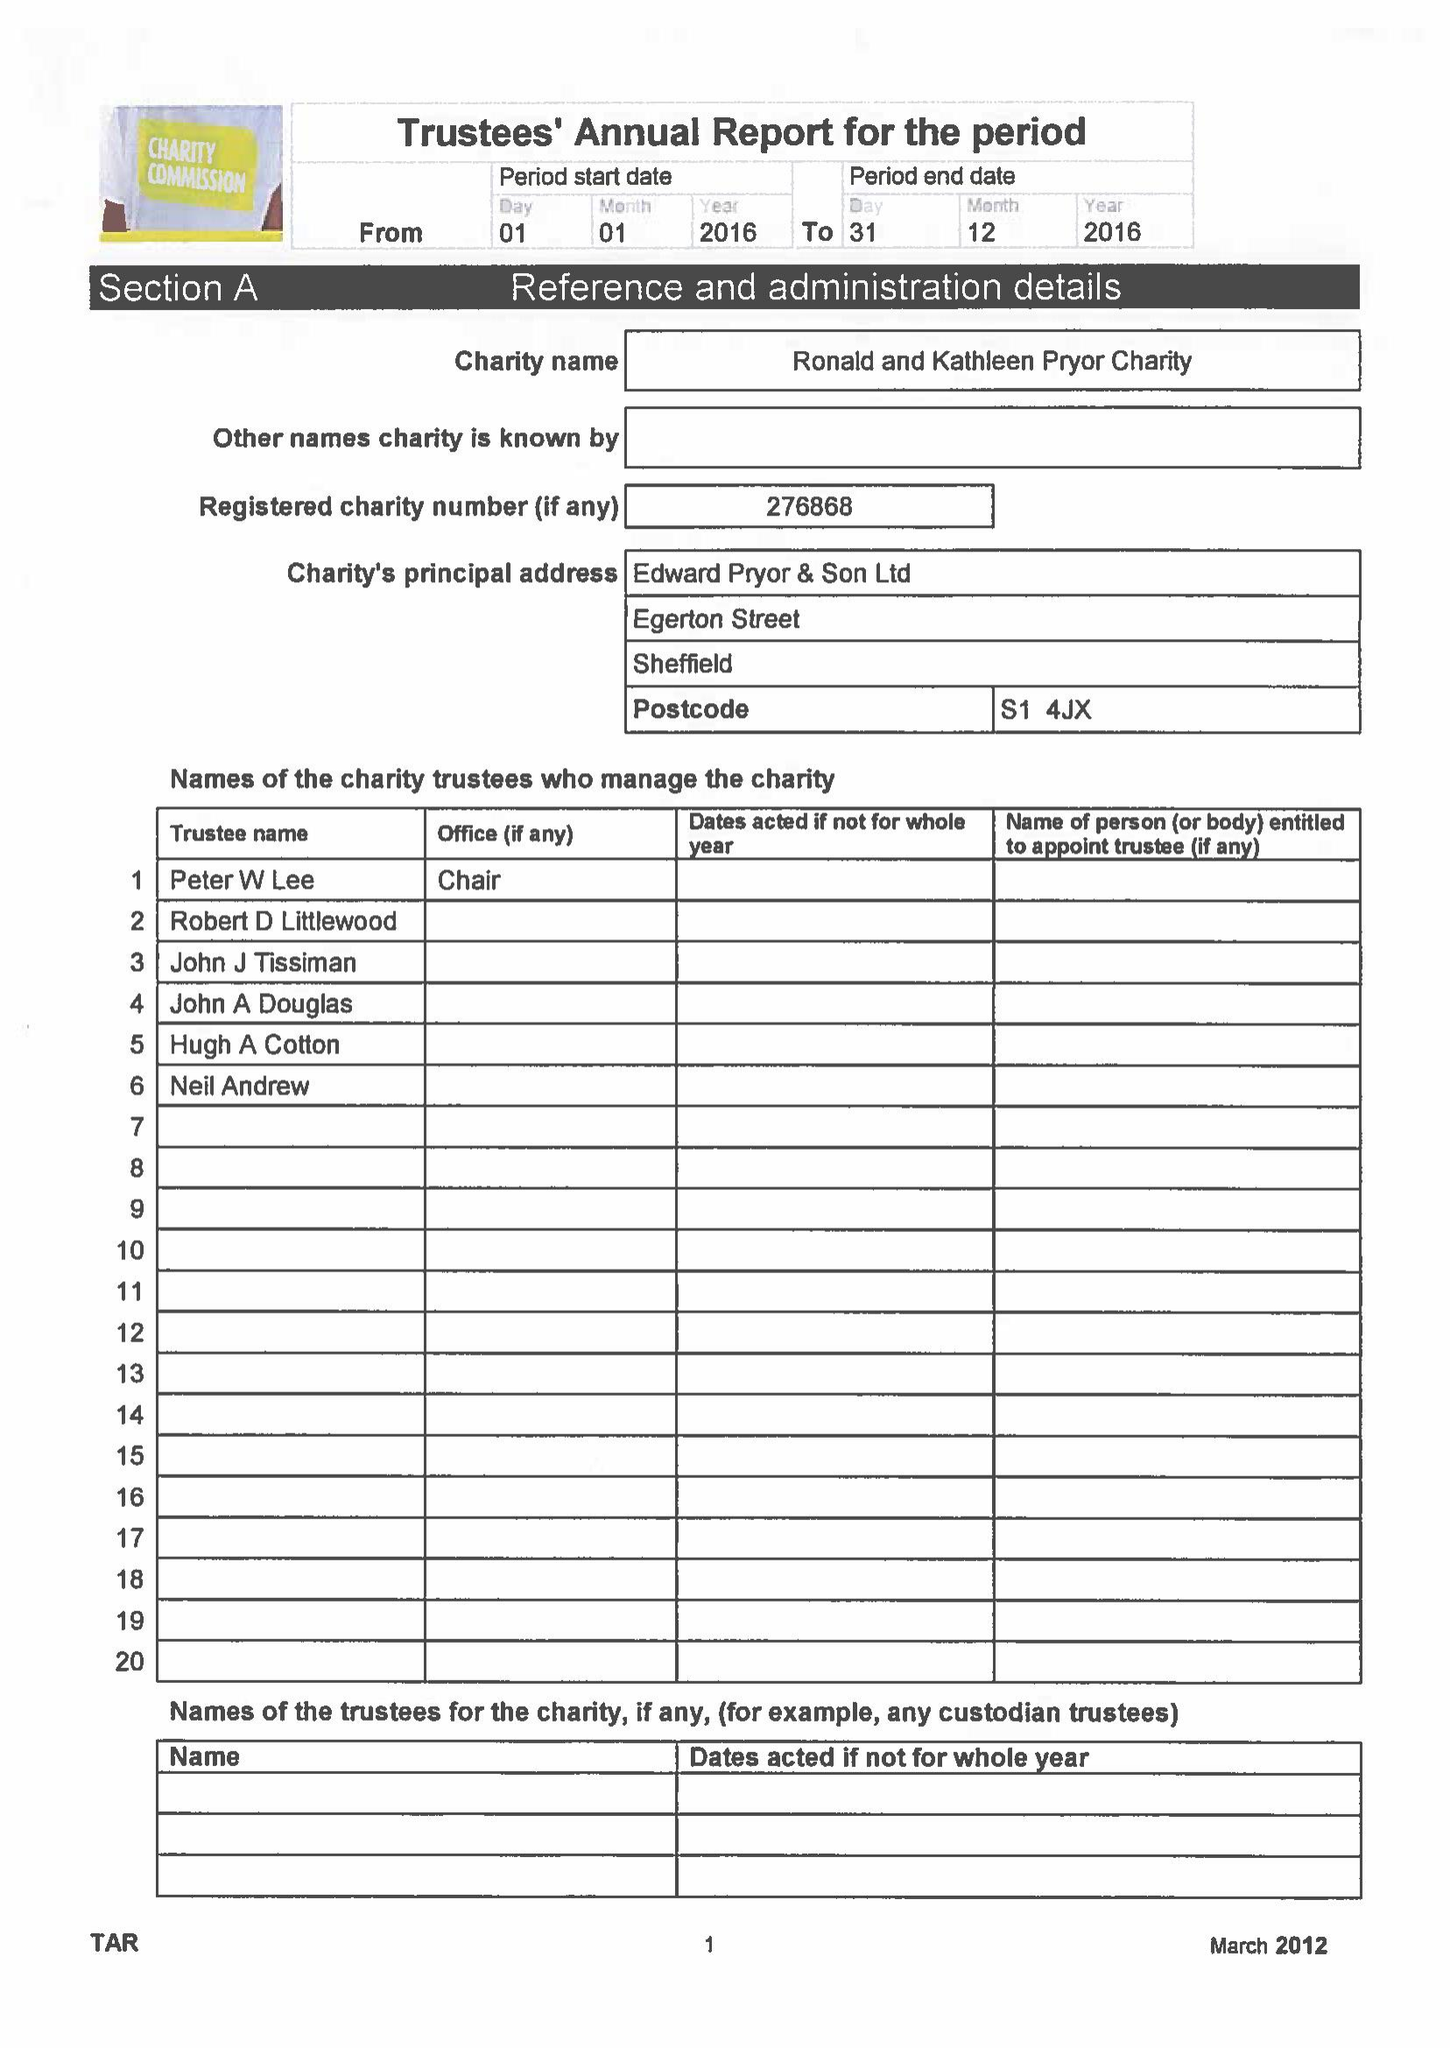What is the value for the address__post_town?
Answer the question using a single word or phrase. SHEFFIELD 